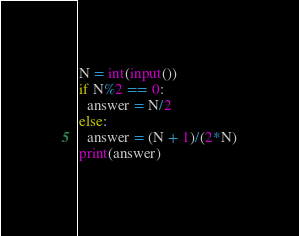<code> <loc_0><loc_0><loc_500><loc_500><_Python_>N = int(input())
if N%2 == 0:
  answer = N/2
else:
  answer = (N + 1)/(2*N)
print(answer)
  </code> 